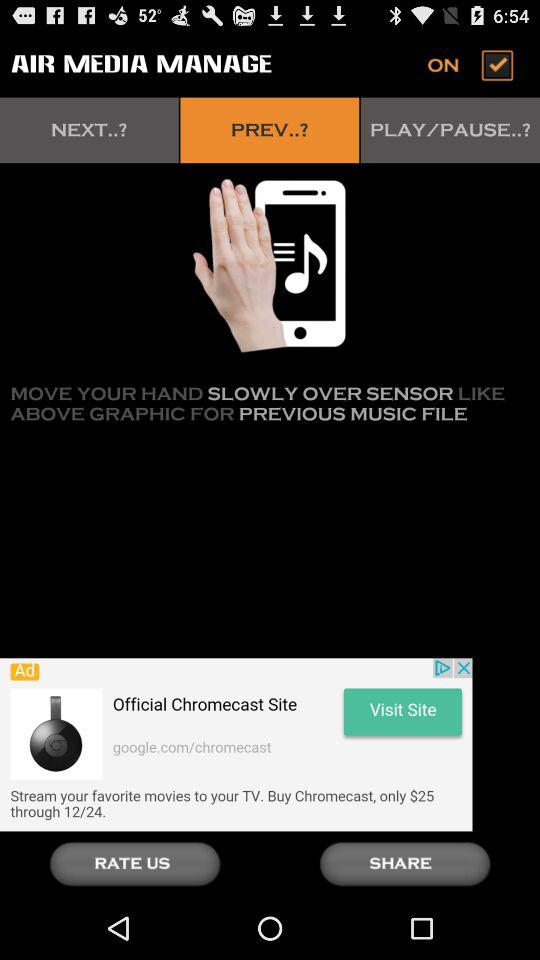What is the status of "AIR MEDIA MANAGE"? The status is "ON". 